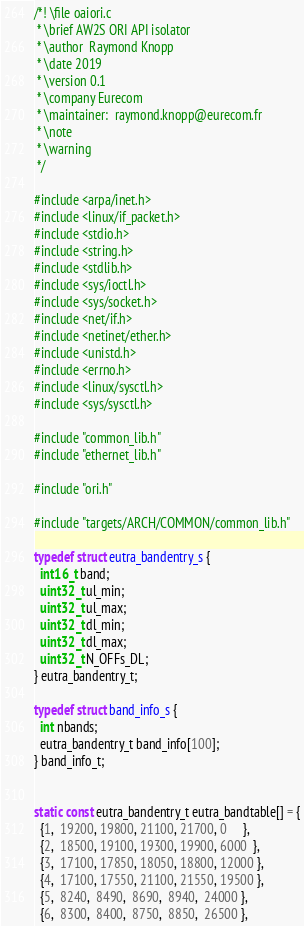<code> <loc_0><loc_0><loc_500><loc_500><_C_>/*! \file oaiori.c
 * \brief AW2S ORI API isolator 
 * \author  Raymond Knopp
 * \date 2019
 * \version 0.1
 * \company Eurecom
 * \maintainer:  raymond.knopp@eurecom.fr
 * \note
 * \warning
 */

#include <arpa/inet.h>
#include <linux/if_packet.h>
#include <stdio.h>
#include <string.h>
#include <stdlib.h>
#include <sys/ioctl.h>
#include <sys/socket.h>
#include <net/if.h>
#include <netinet/ether.h>
#include <unistd.h>
#include <errno.h>
#include <linux/sysctl.h>
#include <sys/sysctl.h>

#include "common_lib.h"
#include "ethernet_lib.h"

#include "ori.h"

#include "targets/ARCH/COMMON/common_lib.h"

typedef struct eutra_bandentry_s {
  int16_t band;
  uint32_t ul_min;
  uint32_t ul_max;
  uint32_t dl_min;
  uint32_t dl_max;
  uint32_t N_OFFs_DL;
} eutra_bandentry_t;

typedef struct band_info_s {
  int nbands;
  eutra_bandentry_t band_info[100];
} band_info_t;


static const eutra_bandentry_t eutra_bandtable[] = {
  {1,  19200, 19800, 21100, 21700, 0     },
  {2,  18500, 19100, 19300, 19900, 6000  },
  {3,  17100, 17850, 18050, 18800, 12000 },
  {4,  17100, 17550, 21100, 21550, 19500 },
  {5,  8240,  8490,  8690,  8940,  24000 },
  {6,  8300,  8400,  8750,  8850,  26500 },</code> 